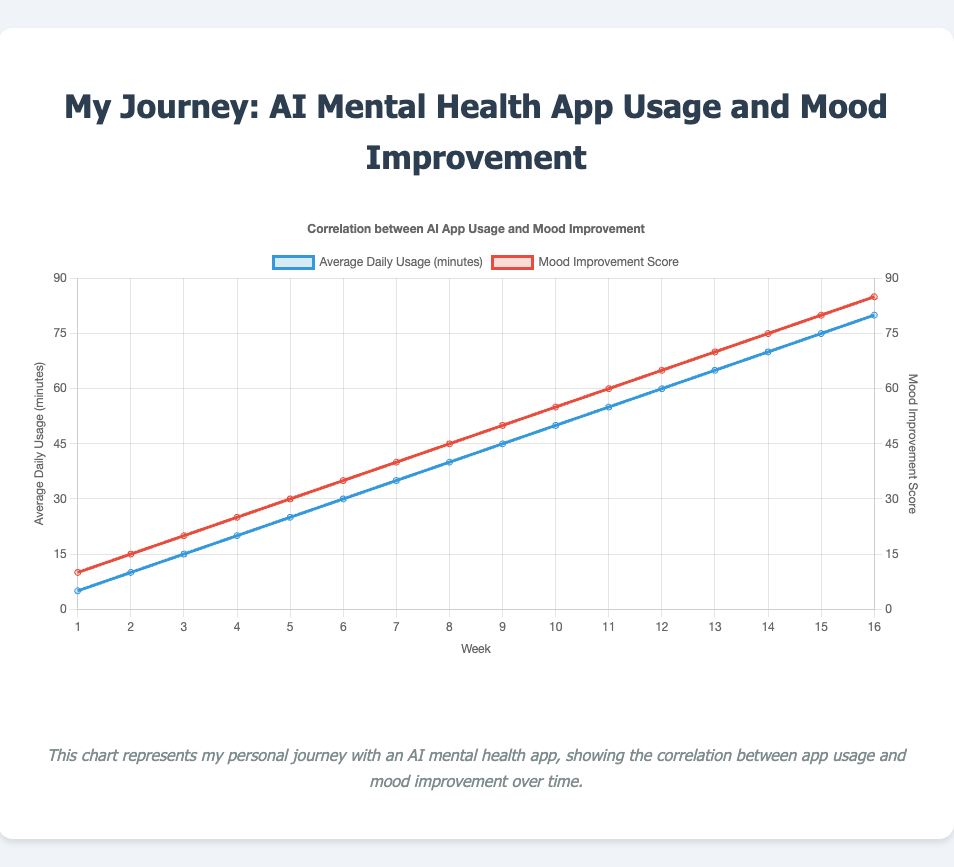What is the mood improvement score at week 8? To find the mood improvement score at week 8, look for the point at week 8 on the x-axis and check the value on the y-axis for the Mood Improvement Score line, which is represented in red.
Answer: 45 How many minutes on average were spent using the app daily during week 10? Find the point on the x-axis at week 10, and check the value on the y-axis for the Average Daily Usage line, which is represented in blue.
Answer: 50 Between which two consecutive weeks was there the largest increase in mood improvement score? Check the differences in the Mood Improvement Score between consecutive weeks. The largest increase (10 points) occurs consistently between each consecutive week.
Answer: Any consecutive weeks; all have equal increases By how much did average daily usage minutes increase from week 1 to week 16? Subtract the average daily usage minutes at week 1 from the average daily usage minutes at week 16: 80 - 5 = 75.
Answer: 75 What is the difference in mood improvement score between week 10 and week 14? Find the Mood Improvement Scores at week 10 (55) and week 14 (75), and subtract the former from the latter: 75 - 55 = 20.
Answer: 20 Which week has the same average daily usage minutes and mood improvement score? Look for the week where both lines intersect. There is no clear week where both scores are exactly the same based on the given data.
Answer: None How does the trend of average daily usage minutes compare to the trend of mood improvement scores from week 1 to week 16? Both the Average Daily Usage minutes and Mood Improvement Scores show a linear, positively correlated increase over the weeks.
Answer: Linear and positively correlated Looking at the visual attributes, which color represents the mood improvement score? Determine which line corresponds to the mood improvement score by checking the legend. The Mood Improvement Score is represented by the red line.
Answer: Red What is the combined value of average daily usage minutes and mood improvement score at week 9? Add the average daily usage minutes (45) and the mood improvement score (50) at week 9: 45 + 50 = 95.
Answer: 95 At which week did the average daily usage minutes first reach 50? Locate the week on the x-axis where the Average Daily Usage line first shows a value of 50; this occurs at week 10.
Answer: Week 10 